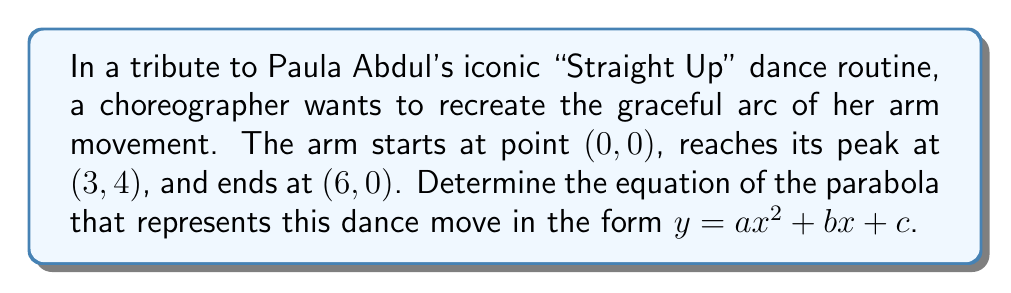Could you help me with this problem? Let's approach this step-by-step:

1) The general form of a parabola is $y = ax^2 + bx + c$, where $a$, $b$, and $c$ are constants and $a \neq 0$.

2) We have three points that the parabola passes through:
   (0, 0), (3, 4), and (6, 0)

3) Substituting these points into the general equation:
   For (0, 0): $0 = a(0)^2 + b(0) + c$ → $c = 0$
   For (3, 4): $4 = a(3)^2 + b(3) + 0$ → $4 = 9a + 3b$
   For (6, 0): $0 = a(6)^2 + b(6) + 0$ → $0 = 36a + 6b$

4) From the last equation: $36a + 6b = 0$ → $6a + b = 0$ → $b = -6a$

5) Substituting this into the second equation:
   $4 = 9a + 3(-6a)$
   $4 = 9a - 18a = -9a$
   $a = -\frac{4}{9}$

6) Now we can find $b$:
   $b = -6a = -6(-\frac{4}{9}) = \frac{24}{9} = \frac{8}{3}$

7) We already know that $c = 0$

Therefore, the equation of the parabola is:
$$y = -\frac{4}{9}x^2 + \frac{8}{3}x$$

[asy]
import graph;
size(200);
real f(real x) {return -4/9*x^2 + 8/3*x;}
draw(graph(f,0,6));
dot((0,0));
dot((3,4));
dot((6,0));
label("(0,0)", (0,0), SW);
label("(3,4)", (3,4), N);
label("(6,0)", (6,0), SE);
xaxis(arrow=Arrow);
yaxis(arrow=Arrow);
[/asy]
Answer: $y = -\frac{4}{9}x^2 + \frac{8}{3}x$ 